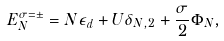<formula> <loc_0><loc_0><loc_500><loc_500>E _ { N } ^ { \sigma = \pm } = N \epsilon _ { d } + U \delta _ { N , 2 } + \frac { \sigma } { 2 } \Phi _ { N } ,</formula> 